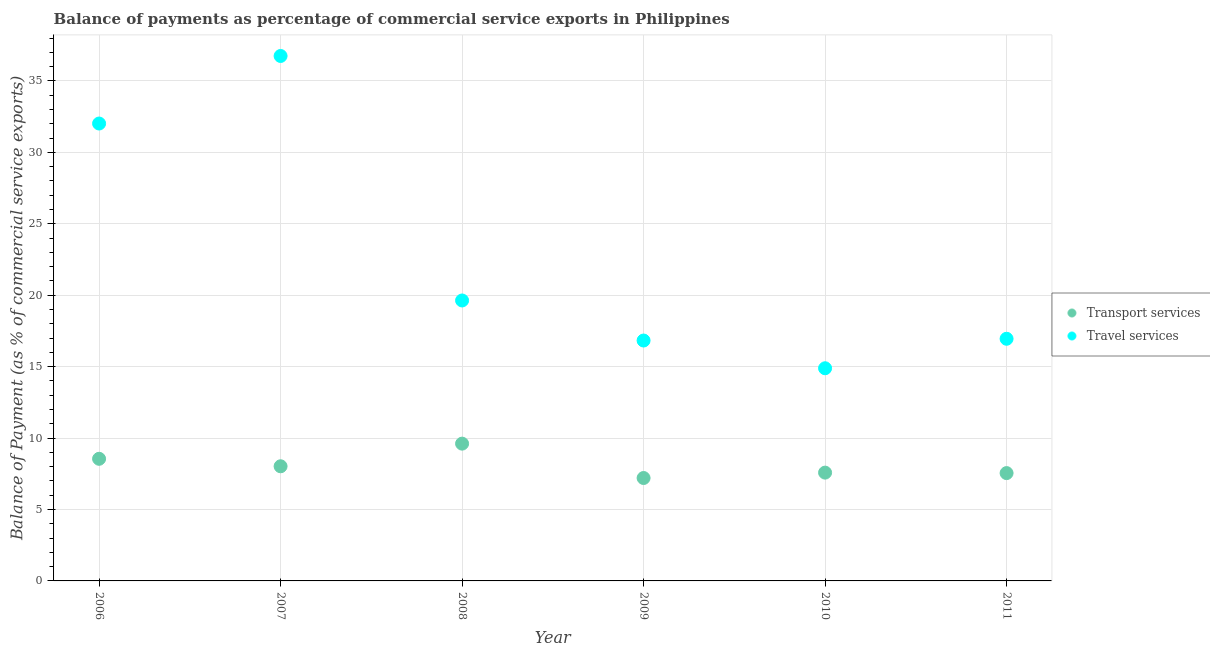What is the balance of payments of travel services in 2007?
Provide a succinct answer. 36.74. Across all years, what is the maximum balance of payments of travel services?
Offer a very short reply. 36.74. Across all years, what is the minimum balance of payments of travel services?
Your response must be concise. 14.88. In which year was the balance of payments of travel services minimum?
Offer a terse response. 2010. What is the total balance of payments of transport services in the graph?
Keep it short and to the point. 48.51. What is the difference between the balance of payments of transport services in 2008 and that in 2010?
Your answer should be compact. 2.03. What is the difference between the balance of payments of travel services in 2010 and the balance of payments of transport services in 2008?
Provide a succinct answer. 5.28. What is the average balance of payments of transport services per year?
Give a very brief answer. 8.09. In the year 2010, what is the difference between the balance of payments of transport services and balance of payments of travel services?
Give a very brief answer. -7.3. What is the ratio of the balance of payments of travel services in 2006 to that in 2009?
Make the answer very short. 1.9. Is the balance of payments of transport services in 2008 less than that in 2009?
Your answer should be very brief. No. What is the difference between the highest and the second highest balance of payments of transport services?
Provide a succinct answer. 1.06. What is the difference between the highest and the lowest balance of payments of travel services?
Your answer should be compact. 21.86. Does the balance of payments of transport services monotonically increase over the years?
Give a very brief answer. No. Is the balance of payments of travel services strictly greater than the balance of payments of transport services over the years?
Your response must be concise. Yes. How many dotlines are there?
Provide a succinct answer. 2. How many years are there in the graph?
Provide a succinct answer. 6. Does the graph contain any zero values?
Give a very brief answer. No. Where does the legend appear in the graph?
Keep it short and to the point. Center right. What is the title of the graph?
Give a very brief answer. Balance of payments as percentage of commercial service exports in Philippines. Does "Banks" appear as one of the legend labels in the graph?
Your answer should be very brief. No. What is the label or title of the X-axis?
Give a very brief answer. Year. What is the label or title of the Y-axis?
Ensure brevity in your answer.  Balance of Payment (as % of commercial service exports). What is the Balance of Payment (as % of commercial service exports) in Transport services in 2006?
Your answer should be compact. 8.55. What is the Balance of Payment (as % of commercial service exports) in Travel services in 2006?
Your response must be concise. 32.02. What is the Balance of Payment (as % of commercial service exports) of Transport services in 2007?
Give a very brief answer. 8.02. What is the Balance of Payment (as % of commercial service exports) in Travel services in 2007?
Offer a terse response. 36.74. What is the Balance of Payment (as % of commercial service exports) in Transport services in 2008?
Offer a very short reply. 9.61. What is the Balance of Payment (as % of commercial service exports) of Travel services in 2008?
Your response must be concise. 19.63. What is the Balance of Payment (as % of commercial service exports) in Transport services in 2009?
Give a very brief answer. 7.2. What is the Balance of Payment (as % of commercial service exports) in Travel services in 2009?
Give a very brief answer. 16.83. What is the Balance of Payment (as % of commercial service exports) of Transport services in 2010?
Provide a short and direct response. 7.58. What is the Balance of Payment (as % of commercial service exports) in Travel services in 2010?
Your answer should be compact. 14.88. What is the Balance of Payment (as % of commercial service exports) in Transport services in 2011?
Provide a succinct answer. 7.55. What is the Balance of Payment (as % of commercial service exports) of Travel services in 2011?
Your answer should be very brief. 16.95. Across all years, what is the maximum Balance of Payment (as % of commercial service exports) of Transport services?
Keep it short and to the point. 9.61. Across all years, what is the maximum Balance of Payment (as % of commercial service exports) in Travel services?
Keep it short and to the point. 36.74. Across all years, what is the minimum Balance of Payment (as % of commercial service exports) of Transport services?
Offer a very short reply. 7.2. Across all years, what is the minimum Balance of Payment (as % of commercial service exports) of Travel services?
Offer a very short reply. 14.88. What is the total Balance of Payment (as % of commercial service exports) in Transport services in the graph?
Give a very brief answer. 48.51. What is the total Balance of Payment (as % of commercial service exports) of Travel services in the graph?
Offer a very short reply. 137.05. What is the difference between the Balance of Payment (as % of commercial service exports) in Transport services in 2006 and that in 2007?
Offer a very short reply. 0.52. What is the difference between the Balance of Payment (as % of commercial service exports) of Travel services in 2006 and that in 2007?
Give a very brief answer. -4.73. What is the difference between the Balance of Payment (as % of commercial service exports) of Transport services in 2006 and that in 2008?
Make the answer very short. -1.06. What is the difference between the Balance of Payment (as % of commercial service exports) of Travel services in 2006 and that in 2008?
Give a very brief answer. 12.39. What is the difference between the Balance of Payment (as % of commercial service exports) of Transport services in 2006 and that in 2009?
Your answer should be very brief. 1.34. What is the difference between the Balance of Payment (as % of commercial service exports) of Travel services in 2006 and that in 2009?
Offer a terse response. 15.19. What is the difference between the Balance of Payment (as % of commercial service exports) of Transport services in 2006 and that in 2010?
Your answer should be very brief. 0.97. What is the difference between the Balance of Payment (as % of commercial service exports) in Travel services in 2006 and that in 2010?
Keep it short and to the point. 17.13. What is the difference between the Balance of Payment (as % of commercial service exports) of Travel services in 2006 and that in 2011?
Provide a succinct answer. 15.07. What is the difference between the Balance of Payment (as % of commercial service exports) of Transport services in 2007 and that in 2008?
Offer a very short reply. -1.58. What is the difference between the Balance of Payment (as % of commercial service exports) of Travel services in 2007 and that in 2008?
Your response must be concise. 17.11. What is the difference between the Balance of Payment (as % of commercial service exports) in Transport services in 2007 and that in 2009?
Your answer should be compact. 0.82. What is the difference between the Balance of Payment (as % of commercial service exports) of Travel services in 2007 and that in 2009?
Provide a short and direct response. 19.92. What is the difference between the Balance of Payment (as % of commercial service exports) of Transport services in 2007 and that in 2010?
Keep it short and to the point. 0.44. What is the difference between the Balance of Payment (as % of commercial service exports) of Travel services in 2007 and that in 2010?
Your response must be concise. 21.86. What is the difference between the Balance of Payment (as % of commercial service exports) in Transport services in 2007 and that in 2011?
Provide a succinct answer. 0.48. What is the difference between the Balance of Payment (as % of commercial service exports) of Travel services in 2007 and that in 2011?
Make the answer very short. 19.79. What is the difference between the Balance of Payment (as % of commercial service exports) in Transport services in 2008 and that in 2009?
Your response must be concise. 2.41. What is the difference between the Balance of Payment (as % of commercial service exports) in Travel services in 2008 and that in 2009?
Keep it short and to the point. 2.8. What is the difference between the Balance of Payment (as % of commercial service exports) in Transport services in 2008 and that in 2010?
Offer a terse response. 2.03. What is the difference between the Balance of Payment (as % of commercial service exports) in Travel services in 2008 and that in 2010?
Your answer should be compact. 4.74. What is the difference between the Balance of Payment (as % of commercial service exports) in Transport services in 2008 and that in 2011?
Ensure brevity in your answer.  2.06. What is the difference between the Balance of Payment (as % of commercial service exports) in Travel services in 2008 and that in 2011?
Your response must be concise. 2.68. What is the difference between the Balance of Payment (as % of commercial service exports) of Transport services in 2009 and that in 2010?
Provide a succinct answer. -0.38. What is the difference between the Balance of Payment (as % of commercial service exports) in Travel services in 2009 and that in 2010?
Your response must be concise. 1.94. What is the difference between the Balance of Payment (as % of commercial service exports) of Transport services in 2009 and that in 2011?
Make the answer very short. -0.34. What is the difference between the Balance of Payment (as % of commercial service exports) of Travel services in 2009 and that in 2011?
Offer a terse response. -0.12. What is the difference between the Balance of Payment (as % of commercial service exports) in Travel services in 2010 and that in 2011?
Provide a short and direct response. -2.06. What is the difference between the Balance of Payment (as % of commercial service exports) in Transport services in 2006 and the Balance of Payment (as % of commercial service exports) in Travel services in 2007?
Your answer should be very brief. -28.2. What is the difference between the Balance of Payment (as % of commercial service exports) in Transport services in 2006 and the Balance of Payment (as % of commercial service exports) in Travel services in 2008?
Keep it short and to the point. -11.08. What is the difference between the Balance of Payment (as % of commercial service exports) in Transport services in 2006 and the Balance of Payment (as % of commercial service exports) in Travel services in 2009?
Offer a terse response. -8.28. What is the difference between the Balance of Payment (as % of commercial service exports) in Transport services in 2006 and the Balance of Payment (as % of commercial service exports) in Travel services in 2010?
Your answer should be compact. -6.34. What is the difference between the Balance of Payment (as % of commercial service exports) in Transport services in 2006 and the Balance of Payment (as % of commercial service exports) in Travel services in 2011?
Give a very brief answer. -8.4. What is the difference between the Balance of Payment (as % of commercial service exports) of Transport services in 2007 and the Balance of Payment (as % of commercial service exports) of Travel services in 2008?
Provide a short and direct response. -11.61. What is the difference between the Balance of Payment (as % of commercial service exports) in Transport services in 2007 and the Balance of Payment (as % of commercial service exports) in Travel services in 2009?
Offer a terse response. -8.8. What is the difference between the Balance of Payment (as % of commercial service exports) of Transport services in 2007 and the Balance of Payment (as % of commercial service exports) of Travel services in 2010?
Provide a succinct answer. -6.86. What is the difference between the Balance of Payment (as % of commercial service exports) in Transport services in 2007 and the Balance of Payment (as % of commercial service exports) in Travel services in 2011?
Offer a terse response. -8.92. What is the difference between the Balance of Payment (as % of commercial service exports) in Transport services in 2008 and the Balance of Payment (as % of commercial service exports) in Travel services in 2009?
Your response must be concise. -7.22. What is the difference between the Balance of Payment (as % of commercial service exports) of Transport services in 2008 and the Balance of Payment (as % of commercial service exports) of Travel services in 2010?
Your response must be concise. -5.28. What is the difference between the Balance of Payment (as % of commercial service exports) of Transport services in 2008 and the Balance of Payment (as % of commercial service exports) of Travel services in 2011?
Make the answer very short. -7.34. What is the difference between the Balance of Payment (as % of commercial service exports) in Transport services in 2009 and the Balance of Payment (as % of commercial service exports) in Travel services in 2010?
Your answer should be very brief. -7.68. What is the difference between the Balance of Payment (as % of commercial service exports) in Transport services in 2009 and the Balance of Payment (as % of commercial service exports) in Travel services in 2011?
Give a very brief answer. -9.75. What is the difference between the Balance of Payment (as % of commercial service exports) in Transport services in 2010 and the Balance of Payment (as % of commercial service exports) in Travel services in 2011?
Your answer should be very brief. -9.37. What is the average Balance of Payment (as % of commercial service exports) in Transport services per year?
Ensure brevity in your answer.  8.09. What is the average Balance of Payment (as % of commercial service exports) in Travel services per year?
Offer a very short reply. 22.84. In the year 2006, what is the difference between the Balance of Payment (as % of commercial service exports) in Transport services and Balance of Payment (as % of commercial service exports) in Travel services?
Ensure brevity in your answer.  -23.47. In the year 2007, what is the difference between the Balance of Payment (as % of commercial service exports) of Transport services and Balance of Payment (as % of commercial service exports) of Travel services?
Offer a terse response. -28.72. In the year 2008, what is the difference between the Balance of Payment (as % of commercial service exports) of Transport services and Balance of Payment (as % of commercial service exports) of Travel services?
Make the answer very short. -10.02. In the year 2009, what is the difference between the Balance of Payment (as % of commercial service exports) in Transport services and Balance of Payment (as % of commercial service exports) in Travel services?
Offer a terse response. -9.62. In the year 2010, what is the difference between the Balance of Payment (as % of commercial service exports) of Transport services and Balance of Payment (as % of commercial service exports) of Travel services?
Offer a very short reply. -7.3. In the year 2011, what is the difference between the Balance of Payment (as % of commercial service exports) of Transport services and Balance of Payment (as % of commercial service exports) of Travel services?
Provide a succinct answer. -9.4. What is the ratio of the Balance of Payment (as % of commercial service exports) of Transport services in 2006 to that in 2007?
Offer a very short reply. 1.07. What is the ratio of the Balance of Payment (as % of commercial service exports) in Travel services in 2006 to that in 2007?
Offer a terse response. 0.87. What is the ratio of the Balance of Payment (as % of commercial service exports) of Transport services in 2006 to that in 2008?
Offer a terse response. 0.89. What is the ratio of the Balance of Payment (as % of commercial service exports) of Travel services in 2006 to that in 2008?
Your response must be concise. 1.63. What is the ratio of the Balance of Payment (as % of commercial service exports) in Transport services in 2006 to that in 2009?
Ensure brevity in your answer.  1.19. What is the ratio of the Balance of Payment (as % of commercial service exports) in Travel services in 2006 to that in 2009?
Make the answer very short. 1.9. What is the ratio of the Balance of Payment (as % of commercial service exports) of Transport services in 2006 to that in 2010?
Your answer should be compact. 1.13. What is the ratio of the Balance of Payment (as % of commercial service exports) of Travel services in 2006 to that in 2010?
Offer a very short reply. 2.15. What is the ratio of the Balance of Payment (as % of commercial service exports) of Transport services in 2006 to that in 2011?
Provide a succinct answer. 1.13. What is the ratio of the Balance of Payment (as % of commercial service exports) of Travel services in 2006 to that in 2011?
Your answer should be compact. 1.89. What is the ratio of the Balance of Payment (as % of commercial service exports) of Transport services in 2007 to that in 2008?
Offer a terse response. 0.84. What is the ratio of the Balance of Payment (as % of commercial service exports) of Travel services in 2007 to that in 2008?
Provide a short and direct response. 1.87. What is the ratio of the Balance of Payment (as % of commercial service exports) in Transport services in 2007 to that in 2009?
Keep it short and to the point. 1.11. What is the ratio of the Balance of Payment (as % of commercial service exports) of Travel services in 2007 to that in 2009?
Your answer should be very brief. 2.18. What is the ratio of the Balance of Payment (as % of commercial service exports) in Transport services in 2007 to that in 2010?
Keep it short and to the point. 1.06. What is the ratio of the Balance of Payment (as % of commercial service exports) in Travel services in 2007 to that in 2010?
Provide a short and direct response. 2.47. What is the ratio of the Balance of Payment (as % of commercial service exports) in Transport services in 2007 to that in 2011?
Provide a short and direct response. 1.06. What is the ratio of the Balance of Payment (as % of commercial service exports) of Travel services in 2007 to that in 2011?
Offer a very short reply. 2.17. What is the ratio of the Balance of Payment (as % of commercial service exports) in Transport services in 2008 to that in 2009?
Provide a succinct answer. 1.33. What is the ratio of the Balance of Payment (as % of commercial service exports) in Travel services in 2008 to that in 2009?
Give a very brief answer. 1.17. What is the ratio of the Balance of Payment (as % of commercial service exports) of Transport services in 2008 to that in 2010?
Offer a very short reply. 1.27. What is the ratio of the Balance of Payment (as % of commercial service exports) of Travel services in 2008 to that in 2010?
Give a very brief answer. 1.32. What is the ratio of the Balance of Payment (as % of commercial service exports) of Transport services in 2008 to that in 2011?
Your answer should be very brief. 1.27. What is the ratio of the Balance of Payment (as % of commercial service exports) of Travel services in 2008 to that in 2011?
Your answer should be compact. 1.16. What is the ratio of the Balance of Payment (as % of commercial service exports) in Transport services in 2009 to that in 2010?
Ensure brevity in your answer.  0.95. What is the ratio of the Balance of Payment (as % of commercial service exports) in Travel services in 2009 to that in 2010?
Your response must be concise. 1.13. What is the ratio of the Balance of Payment (as % of commercial service exports) of Transport services in 2009 to that in 2011?
Your response must be concise. 0.95. What is the ratio of the Balance of Payment (as % of commercial service exports) of Travel services in 2010 to that in 2011?
Provide a succinct answer. 0.88. What is the difference between the highest and the second highest Balance of Payment (as % of commercial service exports) of Transport services?
Make the answer very short. 1.06. What is the difference between the highest and the second highest Balance of Payment (as % of commercial service exports) in Travel services?
Your answer should be compact. 4.73. What is the difference between the highest and the lowest Balance of Payment (as % of commercial service exports) of Transport services?
Your answer should be very brief. 2.41. What is the difference between the highest and the lowest Balance of Payment (as % of commercial service exports) of Travel services?
Keep it short and to the point. 21.86. 